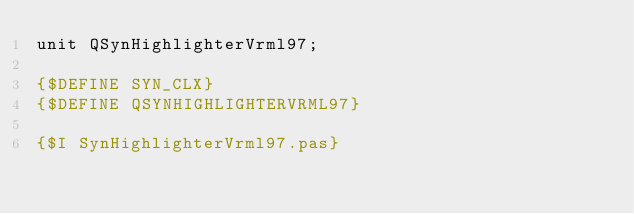<code> <loc_0><loc_0><loc_500><loc_500><_Pascal_>unit QSynHighlighterVrml97;

{$DEFINE SYN_CLX}
{$DEFINE QSYNHIGHLIGHTERVRML97}

{$I SynHighlighterVrml97.pas}
</code> 